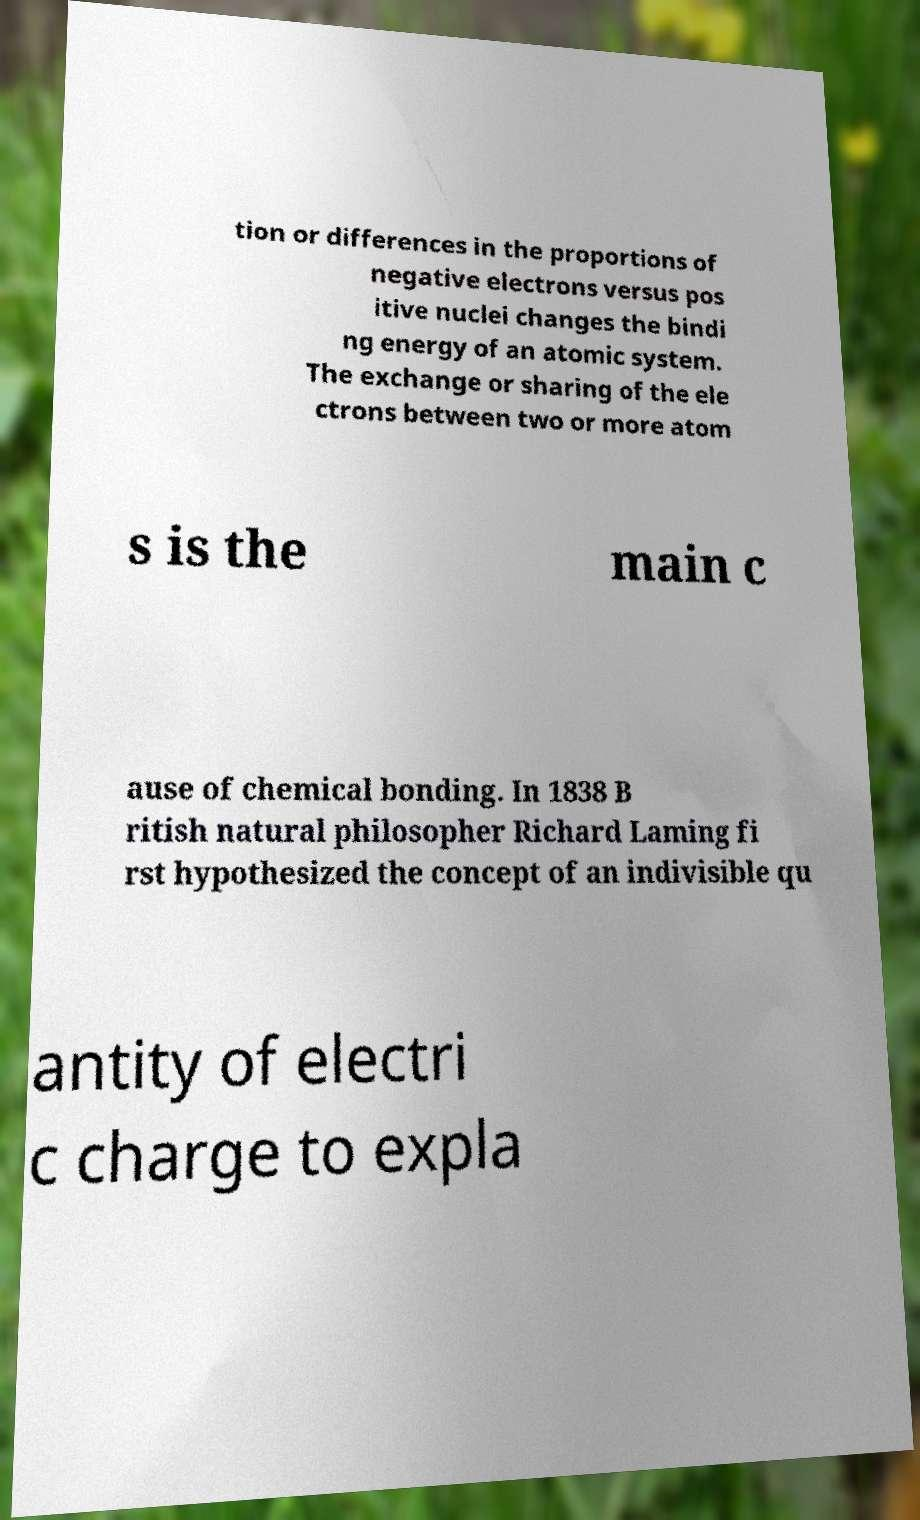I need the written content from this picture converted into text. Can you do that? tion or differences in the proportions of negative electrons versus pos itive nuclei changes the bindi ng energy of an atomic system. The exchange or sharing of the ele ctrons between two or more atom s is the main c ause of chemical bonding. In 1838 B ritish natural philosopher Richard Laming fi rst hypothesized the concept of an indivisible qu antity of electri c charge to expla 